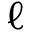<formula> <loc_0><loc_0><loc_500><loc_500>\ell</formula> 